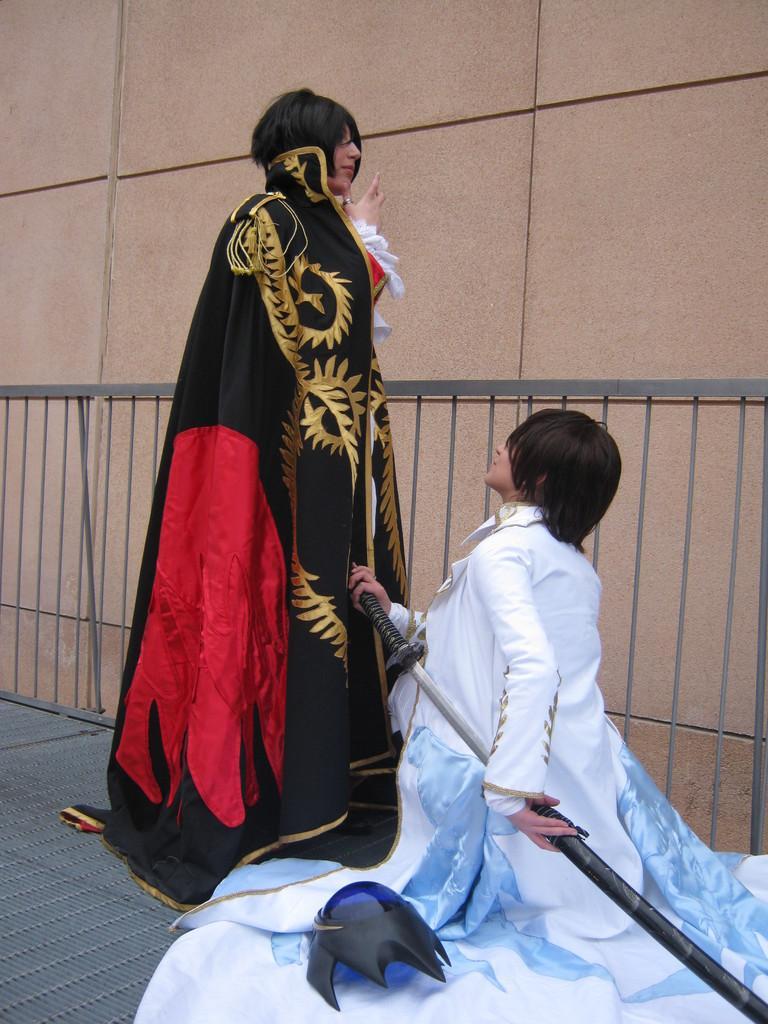Describe this image in one or two sentences. In this image we can see two persons wearing black and white color dress, person wearing white color dress crouching down on the ground also holding sword in hands, we can see a person wearing black color dress standing, we can see iron fencing and there is a wall which is in brown color. 